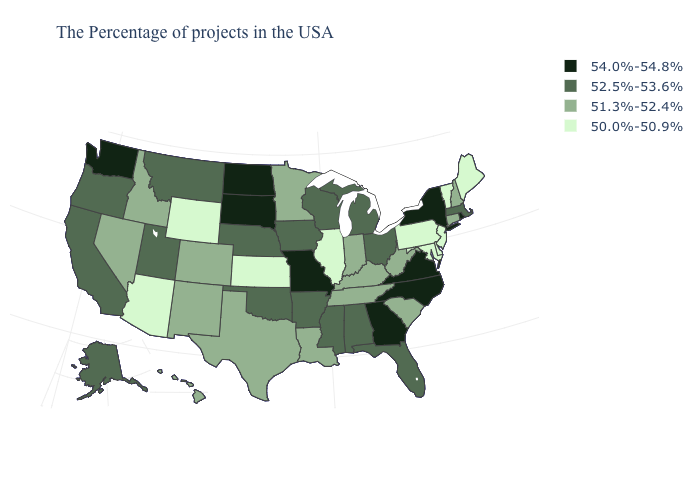Does New Jersey have the same value as Maryland?
Keep it brief. Yes. What is the value of Connecticut?
Concise answer only. 51.3%-52.4%. Does Utah have the highest value in the USA?
Concise answer only. No. Does the map have missing data?
Concise answer only. No. What is the value of Arizona?
Concise answer only. 50.0%-50.9%. Among the states that border Texas , does Louisiana have the lowest value?
Keep it brief. Yes. Among the states that border Arkansas , does Oklahoma have the lowest value?
Quick response, please. No. Among the states that border Colorado , which have the lowest value?
Concise answer only. Kansas, Wyoming, Arizona. Among the states that border Maryland , does West Virginia have the lowest value?
Be succinct. No. What is the value of Washington?
Be succinct. 54.0%-54.8%. What is the highest value in states that border Virginia?
Give a very brief answer. 54.0%-54.8%. What is the highest value in states that border Iowa?
Answer briefly. 54.0%-54.8%. Among the states that border Rhode Island , which have the highest value?
Answer briefly. Massachusetts. Is the legend a continuous bar?
Give a very brief answer. No. Is the legend a continuous bar?
Be succinct. No. 